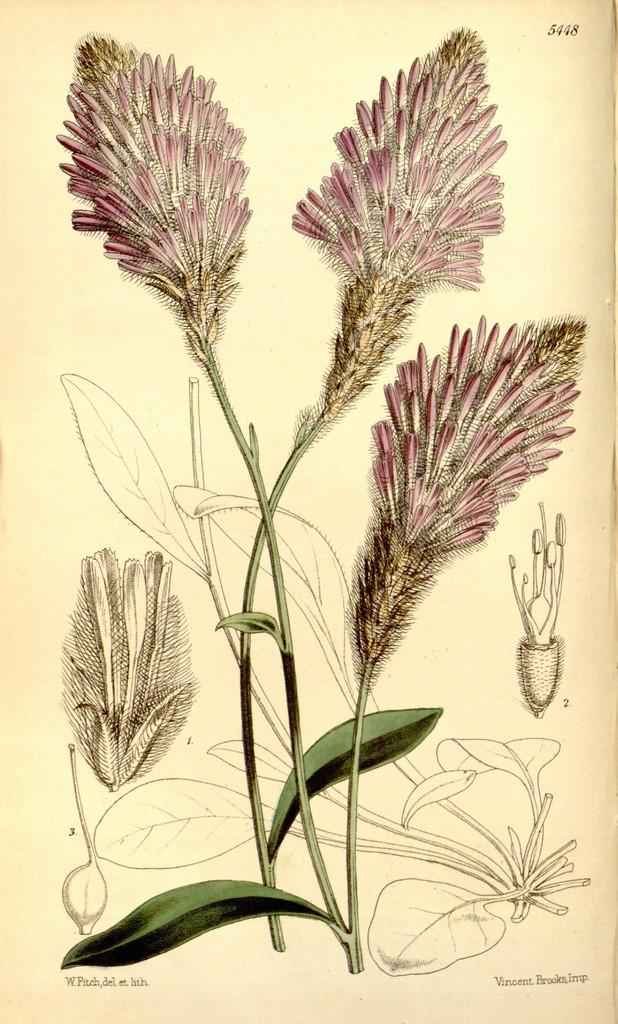What is depicted in the image? There is a picture of a plant with flowers in the image. Is there any text present in the image? Yes, there is text on the image. What type of needle is used to water the plant in the image? There is no needle present in the image, and the plant does not appear to be receiving water. 